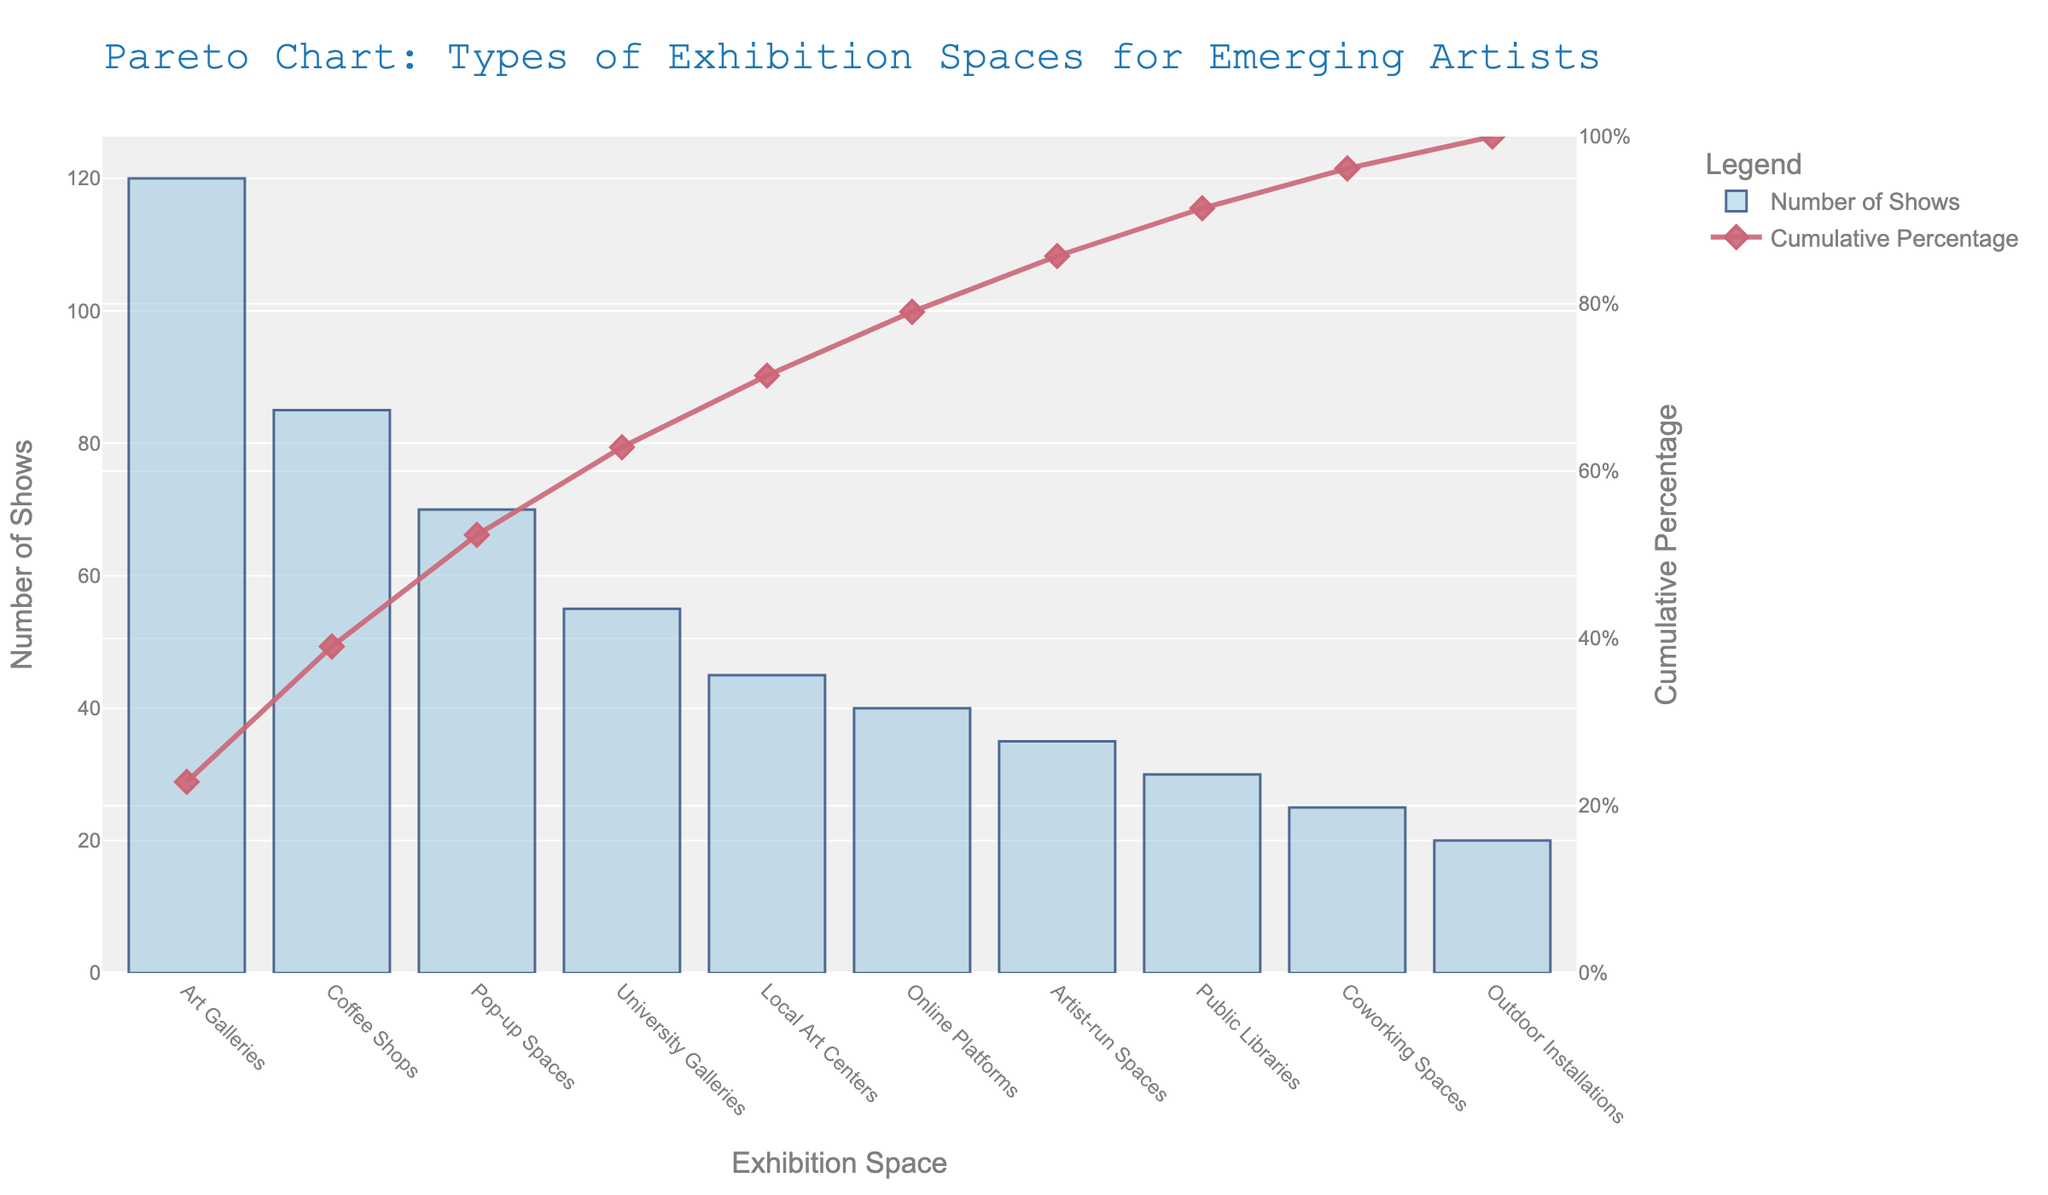What is the title of the chart? The title is usually located at the top of the chart and describes the subject of the data visualization. In this case, it reads, "Pareto Chart: Types of Exhibition Spaces for Emerging Artists".
Answer: Pareto Chart: Types of Exhibition Spaces for Emerging Artists Which exhibition space type has the highest number of shows? The exhibition space with the tallest bar indicates the highest number of shows, which, in this chart, is labeled "Art Galleries".
Answer: Art Galleries What is the cumulative percentage for "Pop-up Spaces"? Locate the "Pop-up Spaces" on the x-axis, then follow upwards to find the corresponding point on the cumulative percentage line (often marked with a dot). Read the value from the secondary y-axis.
Answer: Approximately 72% How many exhibition space types have more than 40 shows? Count the bars that extend beyond the label "40" on the primary y-axis.
Answer: 5 Which exhibition space type is ranked third in terms of the number of shows? Sort the exhibited spaces by the height of their bars in descending order, and identify the third bar.
Answer: Pop-up Spaces What is the cumulative percentage after including "University Galleries"? Add the number of shows for each category in descending order until you include "University Galleries" and calculate their total. Divide this by the total number of shows and convert it to a percentage using the cumulative percentage line.
Answer: Approximately 82% Between "Online Platforms" and "Artist-run Spaces", which one has more shows? Compare the heights of the bars labeled "Online Platforms" and "Artist-run Spaces", the taller bar represents the higher number.
Answer: Online Platforms By how much does the number of shows for "Art Galleries" exceed "Coffee Shops"? Subtract the number of shows for "Coffee Shops" from the number for "Art Galleries". 120 - 85 = 35
Answer: 35 What is the combined number of shows for "Public Libraries" and "Coworking Spaces"? Add the number of shows for "Public Libraries" (30) and "Coworking Spaces" (25). 30 + 25 = 55
Answer: 55 What percentage of shows are covered by the top three exhibition spaces? Calculate the cumulative number of shows for the top three categories and divide it by the total number of shows. Then convert this to a percentage. (120 + 85 + 70) / 525 * 100 ≈ 52.38%
Answer: Approximately 52.4% 